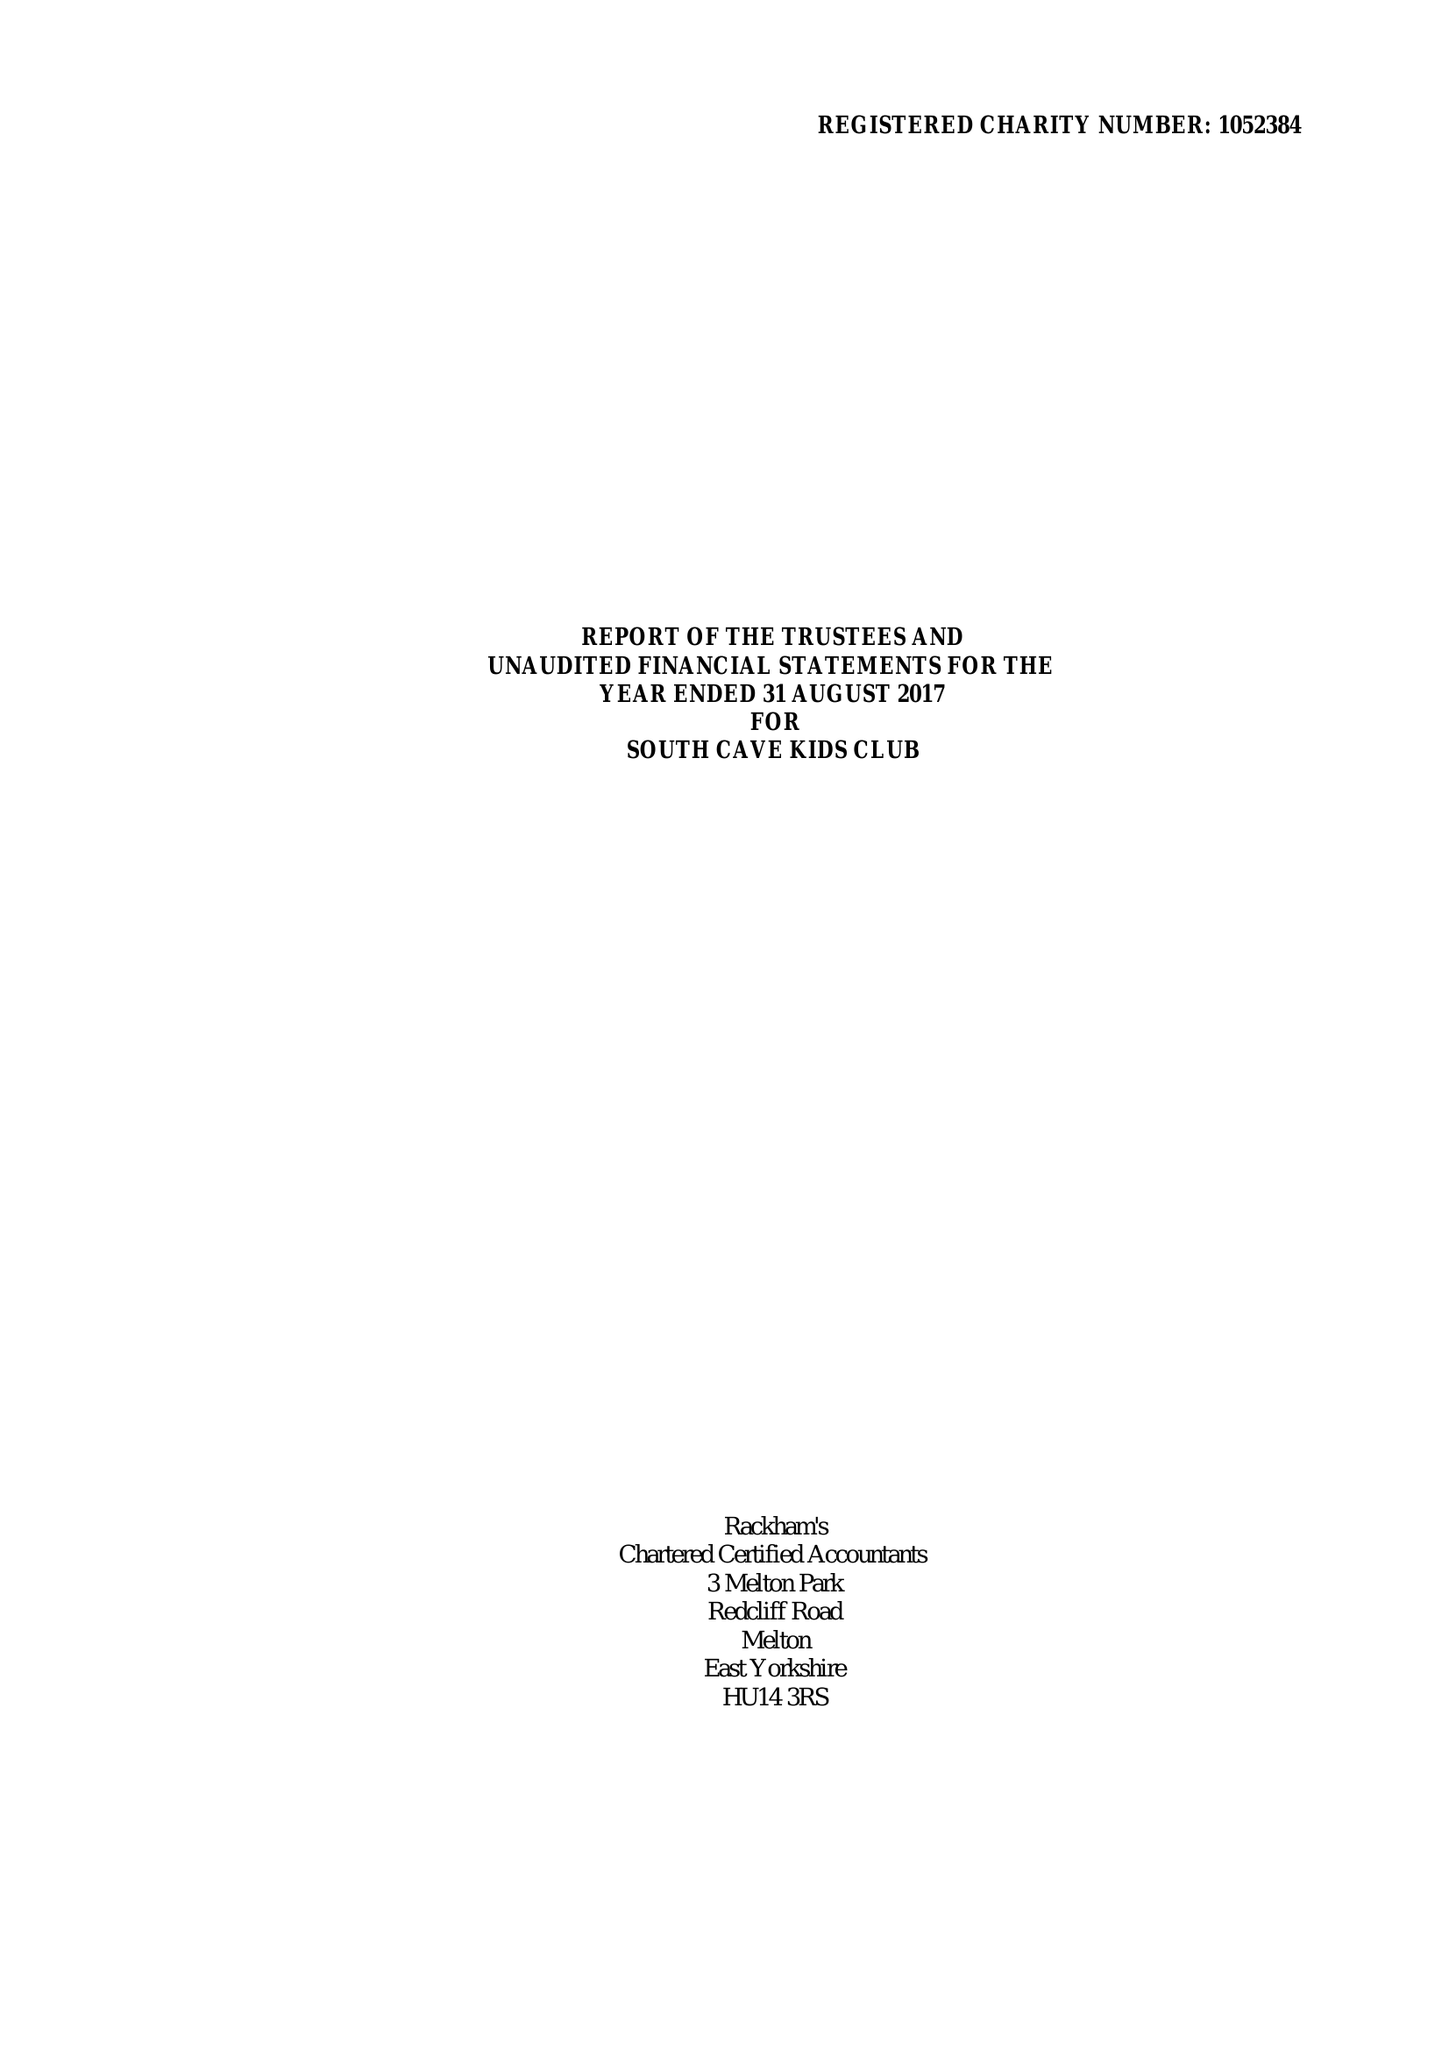What is the value for the spending_annually_in_british_pounds?
Answer the question using a single word or phrase. 171624.00 